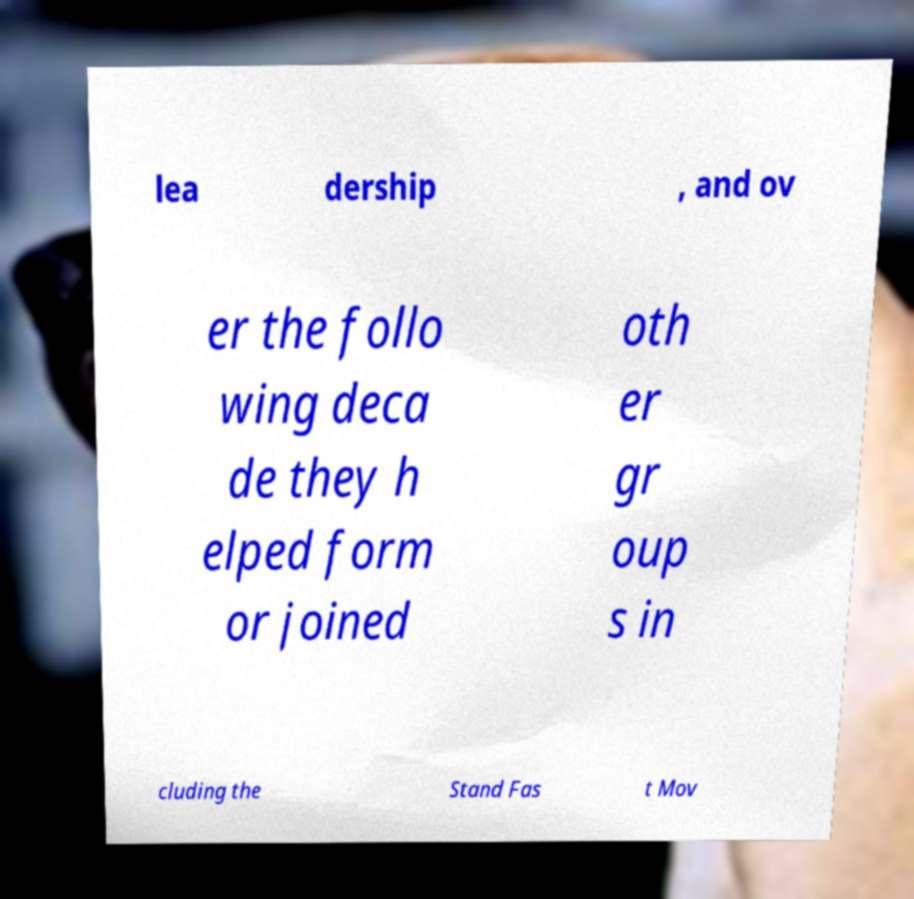Can you read and provide the text displayed in the image?This photo seems to have some interesting text. Can you extract and type it out for me? lea dership , and ov er the follo wing deca de they h elped form or joined oth er gr oup s in cluding the Stand Fas t Mov 